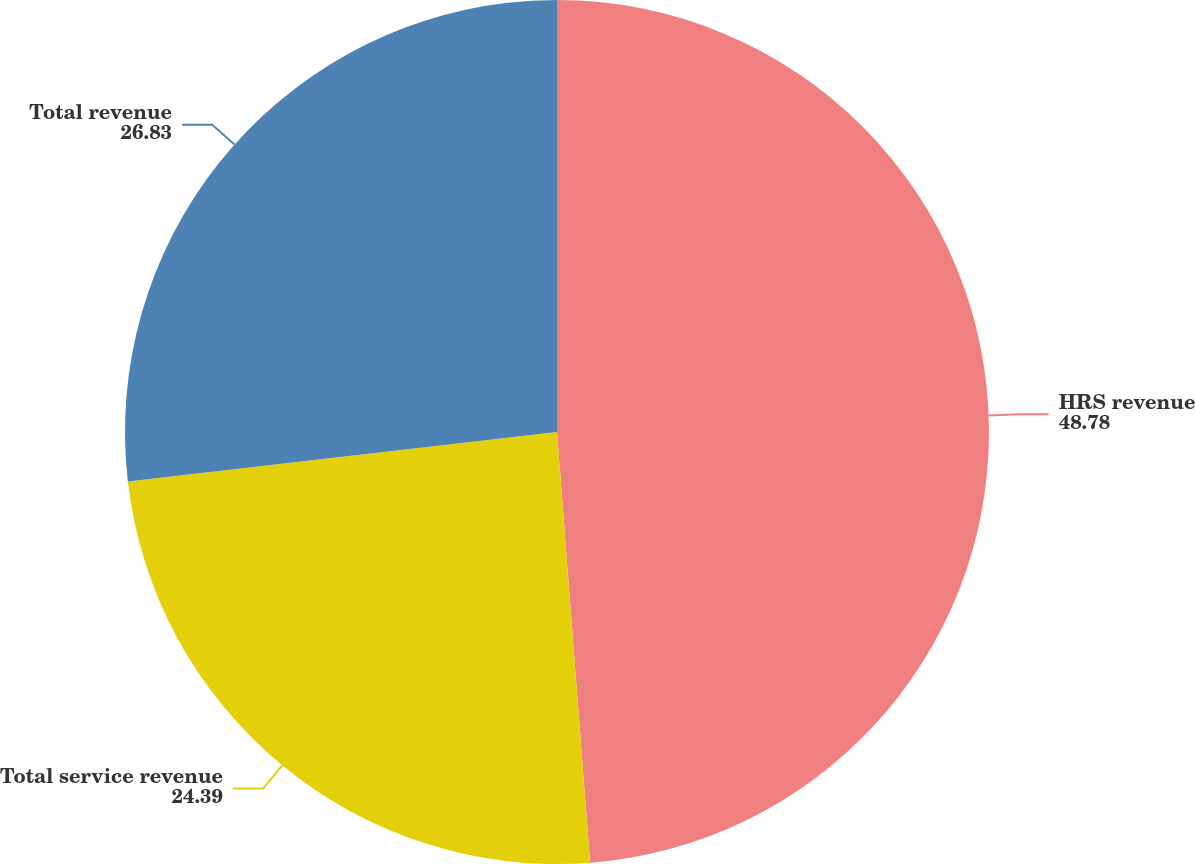<chart> <loc_0><loc_0><loc_500><loc_500><pie_chart><fcel>HRS revenue<fcel>Total service revenue<fcel>Total revenue<nl><fcel>48.78%<fcel>24.39%<fcel>26.83%<nl></chart> 